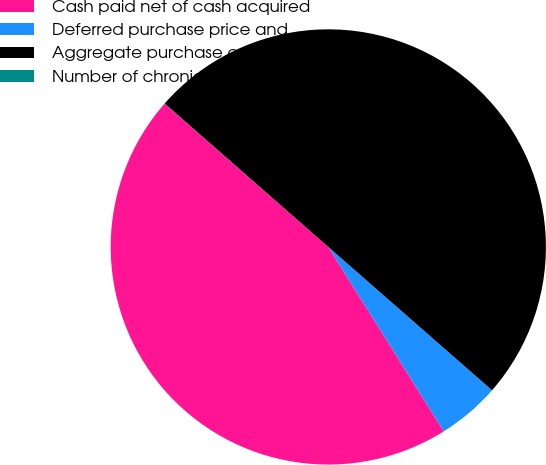Convert chart to OTSL. <chart><loc_0><loc_0><loc_500><loc_500><pie_chart><fcel>Cash paid net of cash acquired<fcel>Deferred purchase price and<fcel>Aggregate purchase cost<fcel>Number of chronic dialysis<nl><fcel>45.35%<fcel>4.65%<fcel>49.99%<fcel>0.01%<nl></chart> 